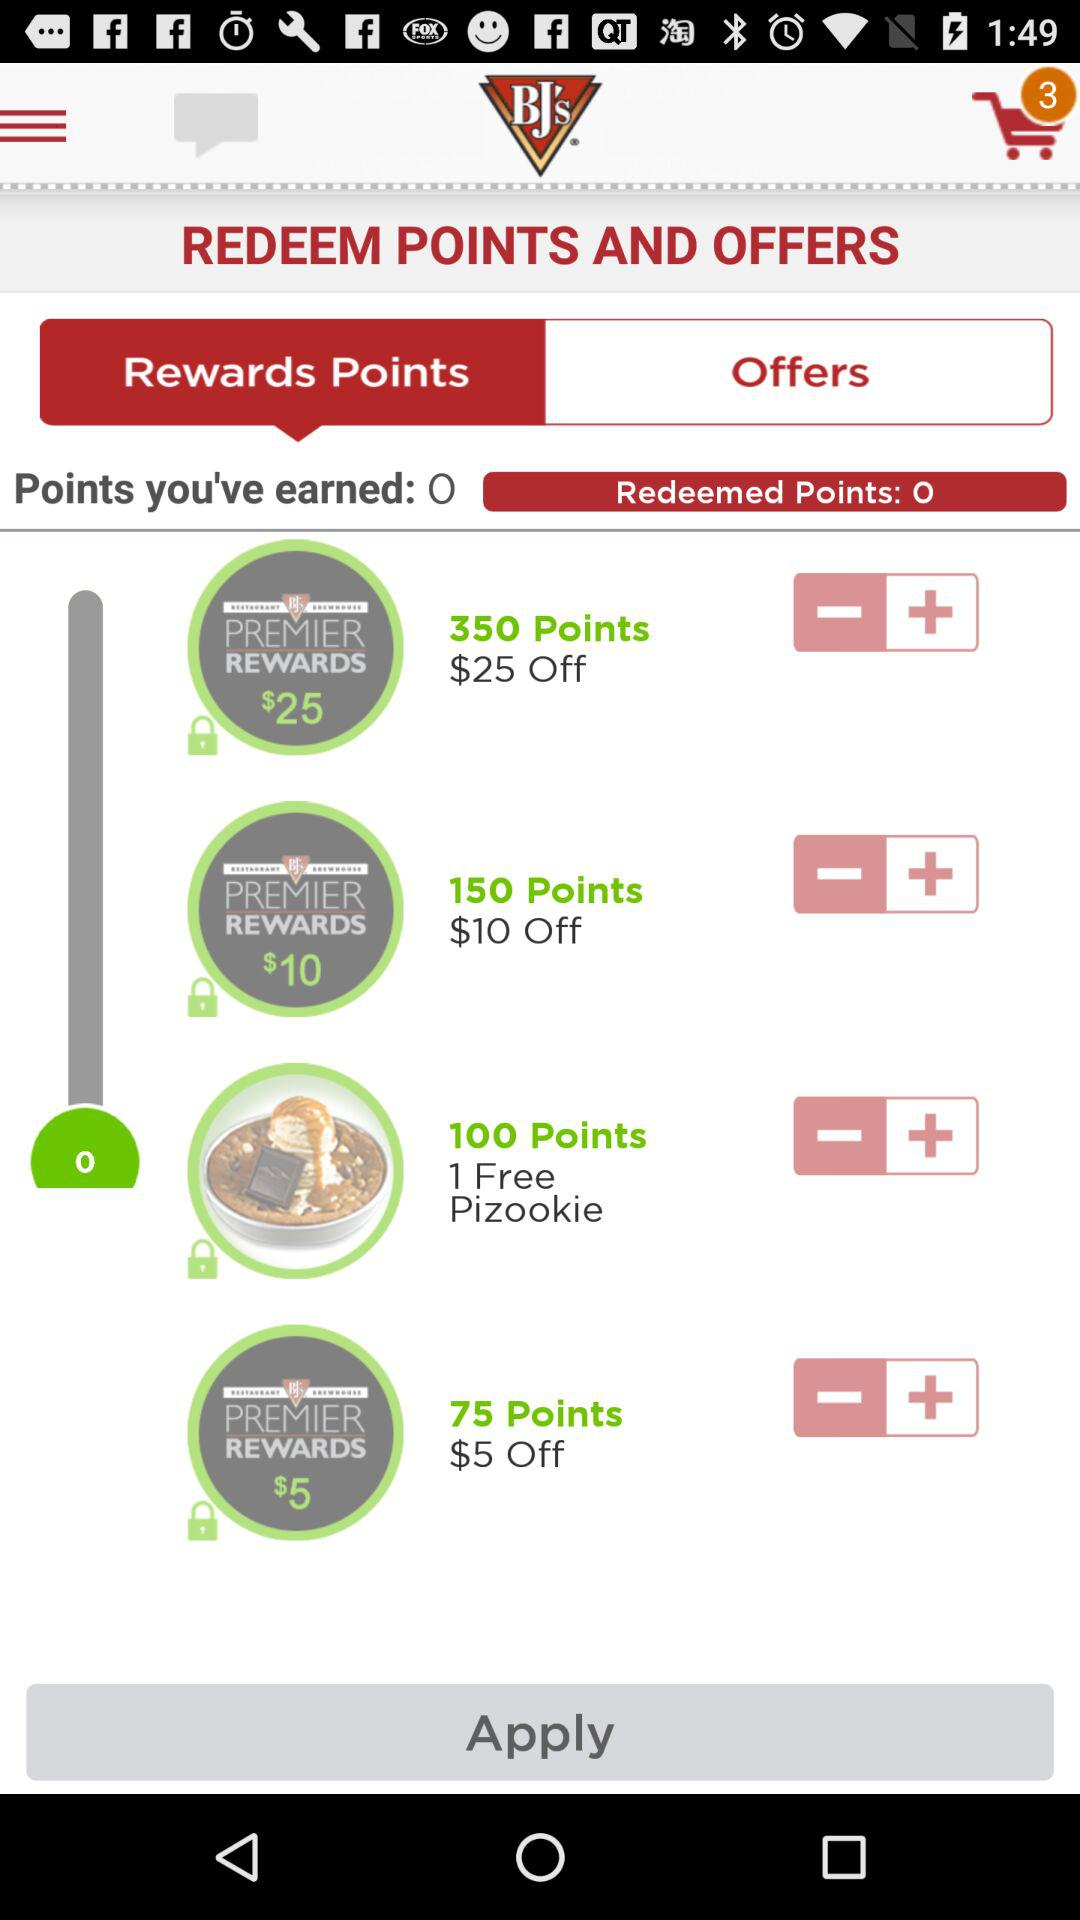How many points are required to redeem the $10 off offer?
Answer the question using a single word or phrase. 150 